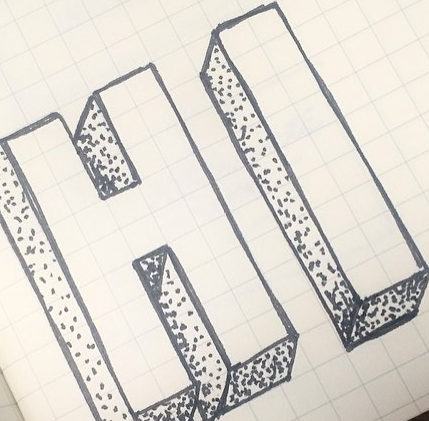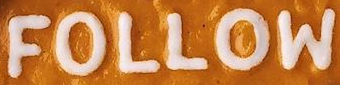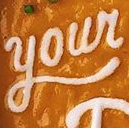Transcribe the words shown in these images in order, separated by a semicolon. HI; FOLLOW; Your 